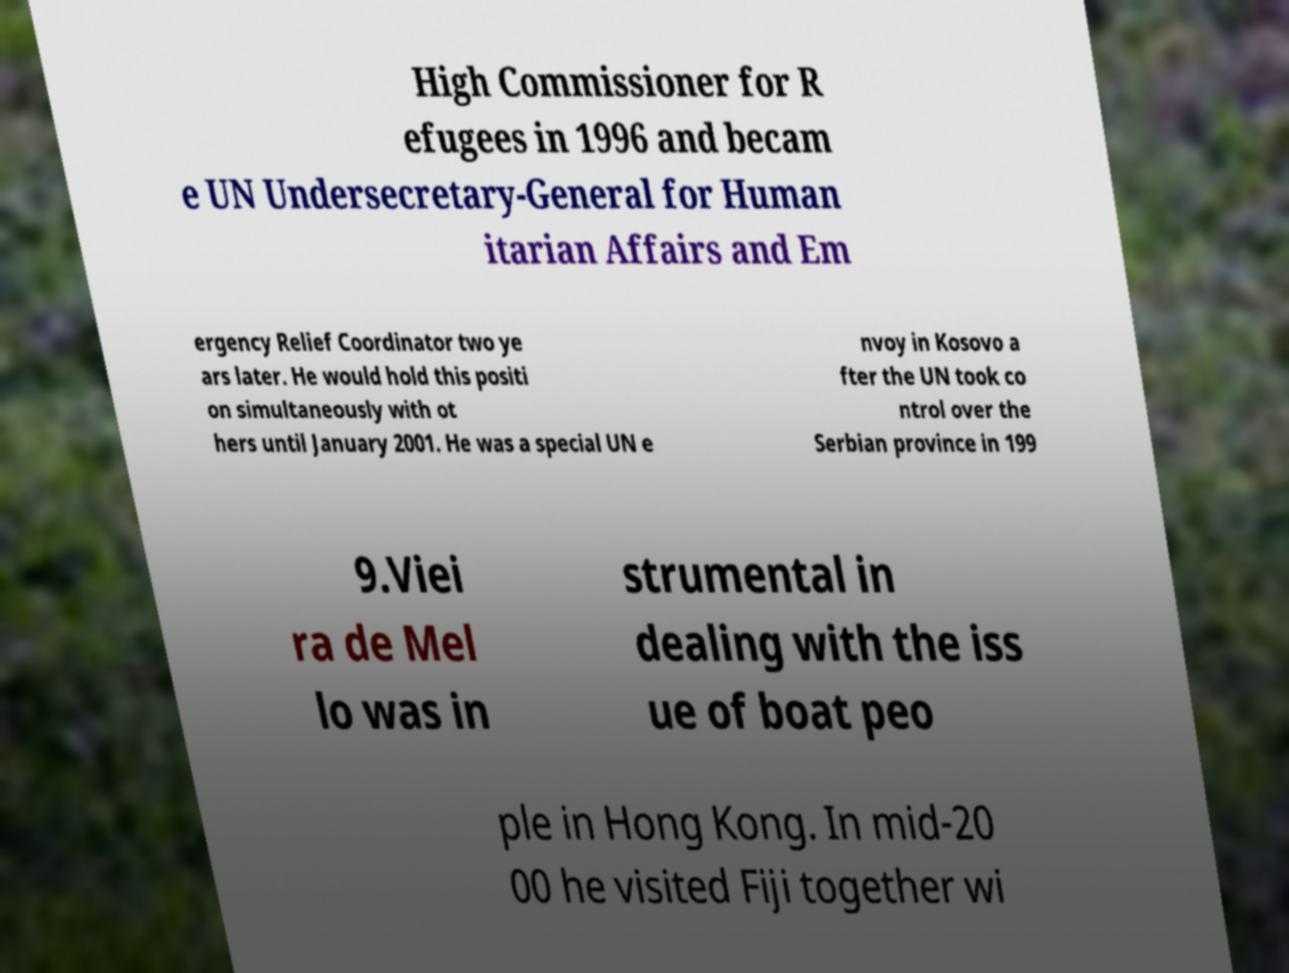Please identify and transcribe the text found in this image. High Commissioner for R efugees in 1996 and becam e UN Undersecretary-General for Human itarian Affairs and Em ergency Relief Coordinator two ye ars later. He would hold this positi on simultaneously with ot hers until January 2001. He was a special UN e nvoy in Kosovo a fter the UN took co ntrol over the Serbian province in 199 9.Viei ra de Mel lo was in strumental in dealing with the iss ue of boat peo ple in Hong Kong. In mid-20 00 he visited Fiji together wi 